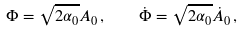<formula> <loc_0><loc_0><loc_500><loc_500>\Phi = \sqrt { 2 \alpha _ { 0 } } A _ { 0 } \, , \quad \dot { \Phi } = \sqrt { 2 \alpha _ { 0 } } \dot { A } _ { 0 } \, ,</formula> 